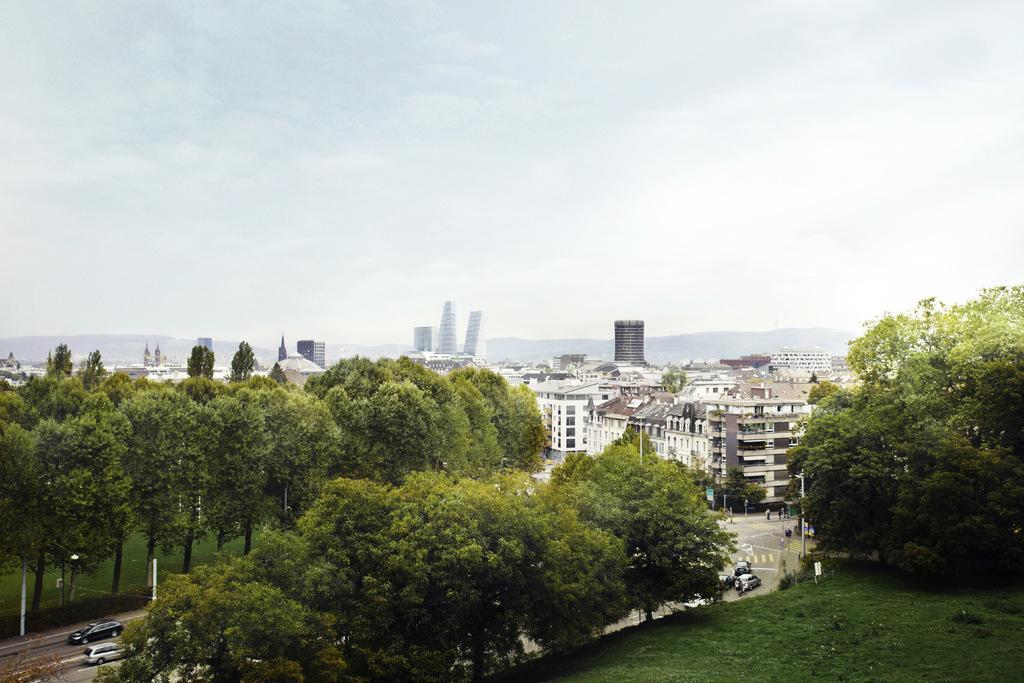In one or two sentences, can you explain what this image depicts? This is an aerial view. In this picture we can see the buildings, trees, mountains, grass, vehicles, road, poles. At the top of the image we can see the clouds are present in the sky. At the bottom of the image we can see the ground. 